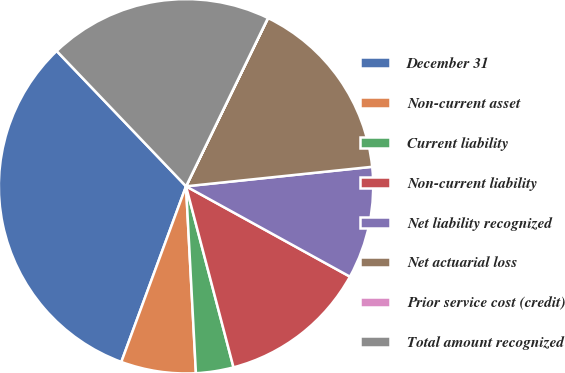Convert chart to OTSL. <chart><loc_0><loc_0><loc_500><loc_500><pie_chart><fcel>December 31<fcel>Non-current asset<fcel>Current liability<fcel>Non-current liability<fcel>Net liability recognized<fcel>Net actuarial loss<fcel>Prior service cost (credit)<fcel>Total amount recognized<nl><fcel>32.24%<fcel>6.46%<fcel>3.24%<fcel>12.9%<fcel>9.68%<fcel>16.12%<fcel>0.01%<fcel>19.35%<nl></chart> 